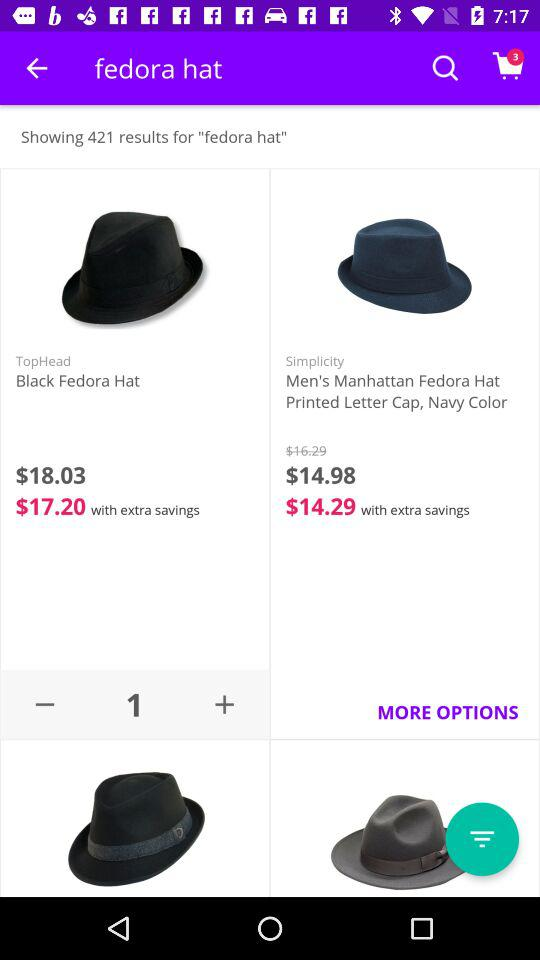How many items are in the cart?
Answer the question using a single word or phrase. 3 